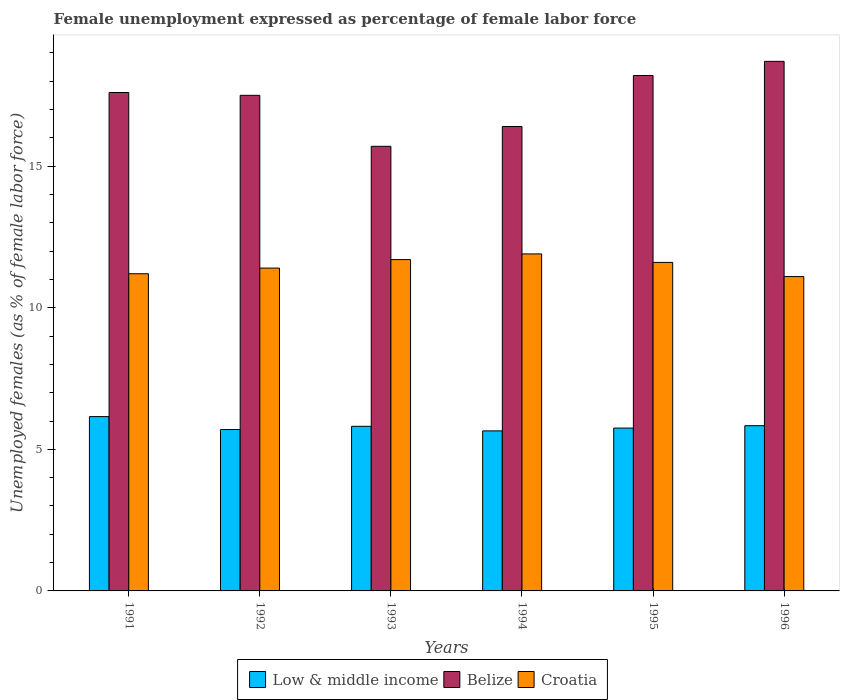How many different coloured bars are there?
Provide a short and direct response. 3. What is the label of the 5th group of bars from the left?
Your answer should be compact. 1995. In how many cases, is the number of bars for a given year not equal to the number of legend labels?
Provide a succinct answer. 0. What is the unemployment in females in in Belize in 1994?
Give a very brief answer. 16.4. Across all years, what is the maximum unemployment in females in in Belize?
Ensure brevity in your answer.  18.7. Across all years, what is the minimum unemployment in females in in Belize?
Provide a short and direct response. 15.7. In which year was the unemployment in females in in Low & middle income maximum?
Your answer should be very brief. 1991. What is the total unemployment in females in in Low & middle income in the graph?
Keep it short and to the point. 34.9. What is the difference between the unemployment in females in in Croatia in 1993 and that in 1994?
Your answer should be compact. -0.2. What is the difference between the unemployment in females in in Low & middle income in 1993 and the unemployment in females in in Croatia in 1995?
Provide a succinct answer. -5.79. What is the average unemployment in females in in Croatia per year?
Make the answer very short. 11.48. In the year 1992, what is the difference between the unemployment in females in in Low & middle income and unemployment in females in in Croatia?
Your answer should be compact. -5.7. What is the ratio of the unemployment in females in in Croatia in 1991 to that in 1996?
Provide a succinct answer. 1.01. Is the difference between the unemployment in females in in Low & middle income in 1991 and 1995 greater than the difference between the unemployment in females in in Croatia in 1991 and 1995?
Give a very brief answer. Yes. What is the difference between the highest and the lowest unemployment in females in in Belize?
Your answer should be very brief. 3. What does the 3rd bar from the left in 1991 represents?
Offer a very short reply. Croatia. What does the 2nd bar from the right in 1996 represents?
Provide a short and direct response. Belize. Is it the case that in every year, the sum of the unemployment in females in in Low & middle income and unemployment in females in in Belize is greater than the unemployment in females in in Croatia?
Make the answer very short. Yes. How many years are there in the graph?
Your answer should be very brief. 6. What is the difference between two consecutive major ticks on the Y-axis?
Give a very brief answer. 5. Are the values on the major ticks of Y-axis written in scientific E-notation?
Keep it short and to the point. No. Does the graph contain any zero values?
Your answer should be very brief. No. How many legend labels are there?
Make the answer very short. 3. How are the legend labels stacked?
Offer a very short reply. Horizontal. What is the title of the graph?
Make the answer very short. Female unemployment expressed as percentage of female labor force. Does "European Union" appear as one of the legend labels in the graph?
Make the answer very short. No. What is the label or title of the X-axis?
Offer a very short reply. Years. What is the label or title of the Y-axis?
Give a very brief answer. Unemployed females (as % of female labor force). What is the Unemployed females (as % of female labor force) in Low & middle income in 1991?
Your answer should be very brief. 6.16. What is the Unemployed females (as % of female labor force) in Belize in 1991?
Provide a succinct answer. 17.6. What is the Unemployed females (as % of female labor force) of Croatia in 1991?
Provide a succinct answer. 11.2. What is the Unemployed females (as % of female labor force) in Low & middle income in 1992?
Keep it short and to the point. 5.7. What is the Unemployed females (as % of female labor force) in Croatia in 1992?
Give a very brief answer. 11.4. What is the Unemployed females (as % of female labor force) in Low & middle income in 1993?
Your response must be concise. 5.81. What is the Unemployed females (as % of female labor force) of Belize in 1993?
Make the answer very short. 15.7. What is the Unemployed females (as % of female labor force) in Croatia in 1993?
Provide a short and direct response. 11.7. What is the Unemployed females (as % of female labor force) of Low & middle income in 1994?
Make the answer very short. 5.65. What is the Unemployed females (as % of female labor force) of Belize in 1994?
Your answer should be very brief. 16.4. What is the Unemployed females (as % of female labor force) in Croatia in 1994?
Offer a very short reply. 11.9. What is the Unemployed females (as % of female labor force) of Low & middle income in 1995?
Ensure brevity in your answer.  5.75. What is the Unemployed females (as % of female labor force) in Belize in 1995?
Your answer should be very brief. 18.2. What is the Unemployed females (as % of female labor force) of Croatia in 1995?
Offer a very short reply. 11.6. What is the Unemployed females (as % of female labor force) of Low & middle income in 1996?
Offer a terse response. 5.83. What is the Unemployed females (as % of female labor force) in Belize in 1996?
Provide a short and direct response. 18.7. What is the Unemployed females (as % of female labor force) in Croatia in 1996?
Keep it short and to the point. 11.1. Across all years, what is the maximum Unemployed females (as % of female labor force) of Low & middle income?
Ensure brevity in your answer.  6.16. Across all years, what is the maximum Unemployed females (as % of female labor force) of Belize?
Your response must be concise. 18.7. Across all years, what is the maximum Unemployed females (as % of female labor force) of Croatia?
Your response must be concise. 11.9. Across all years, what is the minimum Unemployed females (as % of female labor force) of Low & middle income?
Provide a succinct answer. 5.65. Across all years, what is the minimum Unemployed females (as % of female labor force) in Belize?
Provide a succinct answer. 15.7. Across all years, what is the minimum Unemployed females (as % of female labor force) in Croatia?
Your answer should be compact. 11.1. What is the total Unemployed females (as % of female labor force) of Low & middle income in the graph?
Your answer should be very brief. 34.9. What is the total Unemployed females (as % of female labor force) in Belize in the graph?
Offer a very short reply. 104.1. What is the total Unemployed females (as % of female labor force) of Croatia in the graph?
Your response must be concise. 68.9. What is the difference between the Unemployed females (as % of female labor force) in Low & middle income in 1991 and that in 1992?
Provide a short and direct response. 0.46. What is the difference between the Unemployed females (as % of female labor force) in Belize in 1991 and that in 1992?
Give a very brief answer. 0.1. What is the difference between the Unemployed females (as % of female labor force) of Low & middle income in 1991 and that in 1993?
Keep it short and to the point. 0.34. What is the difference between the Unemployed females (as % of female labor force) in Croatia in 1991 and that in 1993?
Ensure brevity in your answer.  -0.5. What is the difference between the Unemployed females (as % of female labor force) in Low & middle income in 1991 and that in 1994?
Offer a terse response. 0.5. What is the difference between the Unemployed females (as % of female labor force) in Low & middle income in 1991 and that in 1995?
Make the answer very short. 0.4. What is the difference between the Unemployed females (as % of female labor force) of Belize in 1991 and that in 1995?
Make the answer very short. -0.6. What is the difference between the Unemployed females (as % of female labor force) of Low & middle income in 1991 and that in 1996?
Provide a succinct answer. 0.32. What is the difference between the Unemployed females (as % of female labor force) of Belize in 1991 and that in 1996?
Make the answer very short. -1.1. What is the difference between the Unemployed females (as % of female labor force) of Croatia in 1991 and that in 1996?
Your response must be concise. 0.1. What is the difference between the Unemployed females (as % of female labor force) of Low & middle income in 1992 and that in 1993?
Provide a short and direct response. -0.11. What is the difference between the Unemployed females (as % of female labor force) of Low & middle income in 1992 and that in 1994?
Offer a very short reply. 0.05. What is the difference between the Unemployed females (as % of female labor force) of Belize in 1992 and that in 1994?
Provide a short and direct response. 1.1. What is the difference between the Unemployed females (as % of female labor force) of Low & middle income in 1992 and that in 1995?
Your answer should be compact. -0.05. What is the difference between the Unemployed females (as % of female labor force) of Croatia in 1992 and that in 1995?
Your answer should be compact. -0.2. What is the difference between the Unemployed females (as % of female labor force) in Low & middle income in 1992 and that in 1996?
Your response must be concise. -0.14. What is the difference between the Unemployed females (as % of female labor force) of Belize in 1992 and that in 1996?
Keep it short and to the point. -1.2. What is the difference between the Unemployed females (as % of female labor force) in Low & middle income in 1993 and that in 1994?
Provide a short and direct response. 0.16. What is the difference between the Unemployed females (as % of female labor force) of Belize in 1993 and that in 1994?
Provide a short and direct response. -0.7. What is the difference between the Unemployed females (as % of female labor force) in Croatia in 1993 and that in 1994?
Offer a very short reply. -0.2. What is the difference between the Unemployed females (as % of female labor force) in Low & middle income in 1993 and that in 1995?
Your response must be concise. 0.06. What is the difference between the Unemployed females (as % of female labor force) in Belize in 1993 and that in 1995?
Ensure brevity in your answer.  -2.5. What is the difference between the Unemployed females (as % of female labor force) of Croatia in 1993 and that in 1995?
Provide a succinct answer. 0.1. What is the difference between the Unemployed females (as % of female labor force) in Low & middle income in 1993 and that in 1996?
Provide a short and direct response. -0.02. What is the difference between the Unemployed females (as % of female labor force) in Low & middle income in 1994 and that in 1995?
Provide a short and direct response. -0.1. What is the difference between the Unemployed females (as % of female labor force) in Belize in 1994 and that in 1995?
Provide a succinct answer. -1.8. What is the difference between the Unemployed females (as % of female labor force) of Croatia in 1994 and that in 1995?
Provide a short and direct response. 0.3. What is the difference between the Unemployed females (as % of female labor force) in Low & middle income in 1994 and that in 1996?
Your response must be concise. -0.18. What is the difference between the Unemployed females (as % of female labor force) in Belize in 1994 and that in 1996?
Provide a short and direct response. -2.3. What is the difference between the Unemployed females (as % of female labor force) in Low & middle income in 1995 and that in 1996?
Give a very brief answer. -0.08. What is the difference between the Unemployed females (as % of female labor force) in Croatia in 1995 and that in 1996?
Ensure brevity in your answer.  0.5. What is the difference between the Unemployed females (as % of female labor force) in Low & middle income in 1991 and the Unemployed females (as % of female labor force) in Belize in 1992?
Provide a succinct answer. -11.34. What is the difference between the Unemployed females (as % of female labor force) in Low & middle income in 1991 and the Unemployed females (as % of female labor force) in Croatia in 1992?
Offer a very short reply. -5.24. What is the difference between the Unemployed females (as % of female labor force) of Low & middle income in 1991 and the Unemployed females (as % of female labor force) of Belize in 1993?
Offer a very short reply. -9.54. What is the difference between the Unemployed females (as % of female labor force) of Low & middle income in 1991 and the Unemployed females (as % of female labor force) of Croatia in 1993?
Your answer should be very brief. -5.54. What is the difference between the Unemployed females (as % of female labor force) in Belize in 1991 and the Unemployed females (as % of female labor force) in Croatia in 1993?
Make the answer very short. 5.9. What is the difference between the Unemployed females (as % of female labor force) in Low & middle income in 1991 and the Unemployed females (as % of female labor force) in Belize in 1994?
Give a very brief answer. -10.24. What is the difference between the Unemployed females (as % of female labor force) in Low & middle income in 1991 and the Unemployed females (as % of female labor force) in Croatia in 1994?
Offer a terse response. -5.74. What is the difference between the Unemployed females (as % of female labor force) of Low & middle income in 1991 and the Unemployed females (as % of female labor force) of Belize in 1995?
Give a very brief answer. -12.04. What is the difference between the Unemployed females (as % of female labor force) in Low & middle income in 1991 and the Unemployed females (as % of female labor force) in Croatia in 1995?
Your answer should be compact. -5.44. What is the difference between the Unemployed females (as % of female labor force) in Low & middle income in 1991 and the Unemployed females (as % of female labor force) in Belize in 1996?
Your answer should be very brief. -12.54. What is the difference between the Unemployed females (as % of female labor force) of Low & middle income in 1991 and the Unemployed females (as % of female labor force) of Croatia in 1996?
Your answer should be compact. -4.94. What is the difference between the Unemployed females (as % of female labor force) of Low & middle income in 1992 and the Unemployed females (as % of female labor force) of Belize in 1993?
Offer a very short reply. -10. What is the difference between the Unemployed females (as % of female labor force) in Low & middle income in 1992 and the Unemployed females (as % of female labor force) in Croatia in 1993?
Your answer should be compact. -6. What is the difference between the Unemployed females (as % of female labor force) in Low & middle income in 1992 and the Unemployed females (as % of female labor force) in Belize in 1994?
Make the answer very short. -10.7. What is the difference between the Unemployed females (as % of female labor force) of Low & middle income in 1992 and the Unemployed females (as % of female labor force) of Croatia in 1994?
Your answer should be compact. -6.2. What is the difference between the Unemployed females (as % of female labor force) of Belize in 1992 and the Unemployed females (as % of female labor force) of Croatia in 1994?
Make the answer very short. 5.6. What is the difference between the Unemployed females (as % of female labor force) of Low & middle income in 1992 and the Unemployed females (as % of female labor force) of Belize in 1995?
Provide a short and direct response. -12.5. What is the difference between the Unemployed females (as % of female labor force) of Low & middle income in 1992 and the Unemployed females (as % of female labor force) of Croatia in 1995?
Provide a succinct answer. -5.9. What is the difference between the Unemployed females (as % of female labor force) in Low & middle income in 1992 and the Unemployed females (as % of female labor force) in Belize in 1996?
Provide a succinct answer. -13. What is the difference between the Unemployed females (as % of female labor force) of Low & middle income in 1992 and the Unemployed females (as % of female labor force) of Croatia in 1996?
Provide a short and direct response. -5.4. What is the difference between the Unemployed females (as % of female labor force) in Belize in 1992 and the Unemployed females (as % of female labor force) in Croatia in 1996?
Offer a terse response. 6.4. What is the difference between the Unemployed females (as % of female labor force) of Low & middle income in 1993 and the Unemployed females (as % of female labor force) of Belize in 1994?
Your response must be concise. -10.59. What is the difference between the Unemployed females (as % of female labor force) of Low & middle income in 1993 and the Unemployed females (as % of female labor force) of Croatia in 1994?
Your answer should be compact. -6.09. What is the difference between the Unemployed females (as % of female labor force) of Belize in 1993 and the Unemployed females (as % of female labor force) of Croatia in 1994?
Give a very brief answer. 3.8. What is the difference between the Unemployed females (as % of female labor force) of Low & middle income in 1993 and the Unemployed females (as % of female labor force) of Belize in 1995?
Keep it short and to the point. -12.39. What is the difference between the Unemployed females (as % of female labor force) in Low & middle income in 1993 and the Unemployed females (as % of female labor force) in Croatia in 1995?
Give a very brief answer. -5.79. What is the difference between the Unemployed females (as % of female labor force) in Low & middle income in 1993 and the Unemployed females (as % of female labor force) in Belize in 1996?
Provide a succinct answer. -12.89. What is the difference between the Unemployed females (as % of female labor force) in Low & middle income in 1993 and the Unemployed females (as % of female labor force) in Croatia in 1996?
Keep it short and to the point. -5.29. What is the difference between the Unemployed females (as % of female labor force) of Low & middle income in 1994 and the Unemployed females (as % of female labor force) of Belize in 1995?
Keep it short and to the point. -12.55. What is the difference between the Unemployed females (as % of female labor force) of Low & middle income in 1994 and the Unemployed females (as % of female labor force) of Croatia in 1995?
Offer a terse response. -5.95. What is the difference between the Unemployed females (as % of female labor force) in Belize in 1994 and the Unemployed females (as % of female labor force) in Croatia in 1995?
Ensure brevity in your answer.  4.8. What is the difference between the Unemployed females (as % of female labor force) in Low & middle income in 1994 and the Unemployed females (as % of female labor force) in Belize in 1996?
Offer a terse response. -13.05. What is the difference between the Unemployed females (as % of female labor force) in Low & middle income in 1994 and the Unemployed females (as % of female labor force) in Croatia in 1996?
Provide a short and direct response. -5.45. What is the difference between the Unemployed females (as % of female labor force) in Low & middle income in 1995 and the Unemployed females (as % of female labor force) in Belize in 1996?
Your answer should be very brief. -12.95. What is the difference between the Unemployed females (as % of female labor force) in Low & middle income in 1995 and the Unemployed females (as % of female labor force) in Croatia in 1996?
Ensure brevity in your answer.  -5.35. What is the difference between the Unemployed females (as % of female labor force) in Belize in 1995 and the Unemployed females (as % of female labor force) in Croatia in 1996?
Make the answer very short. 7.1. What is the average Unemployed females (as % of female labor force) in Low & middle income per year?
Provide a succinct answer. 5.82. What is the average Unemployed females (as % of female labor force) in Belize per year?
Your answer should be compact. 17.35. What is the average Unemployed females (as % of female labor force) in Croatia per year?
Ensure brevity in your answer.  11.48. In the year 1991, what is the difference between the Unemployed females (as % of female labor force) of Low & middle income and Unemployed females (as % of female labor force) of Belize?
Keep it short and to the point. -11.44. In the year 1991, what is the difference between the Unemployed females (as % of female labor force) in Low & middle income and Unemployed females (as % of female labor force) in Croatia?
Ensure brevity in your answer.  -5.04. In the year 1991, what is the difference between the Unemployed females (as % of female labor force) in Belize and Unemployed females (as % of female labor force) in Croatia?
Make the answer very short. 6.4. In the year 1992, what is the difference between the Unemployed females (as % of female labor force) in Low & middle income and Unemployed females (as % of female labor force) in Belize?
Offer a terse response. -11.8. In the year 1992, what is the difference between the Unemployed females (as % of female labor force) in Low & middle income and Unemployed females (as % of female labor force) in Croatia?
Offer a terse response. -5.7. In the year 1992, what is the difference between the Unemployed females (as % of female labor force) in Belize and Unemployed females (as % of female labor force) in Croatia?
Offer a very short reply. 6.1. In the year 1993, what is the difference between the Unemployed females (as % of female labor force) in Low & middle income and Unemployed females (as % of female labor force) in Belize?
Provide a short and direct response. -9.89. In the year 1993, what is the difference between the Unemployed females (as % of female labor force) of Low & middle income and Unemployed females (as % of female labor force) of Croatia?
Your answer should be compact. -5.89. In the year 1994, what is the difference between the Unemployed females (as % of female labor force) of Low & middle income and Unemployed females (as % of female labor force) of Belize?
Provide a succinct answer. -10.75. In the year 1994, what is the difference between the Unemployed females (as % of female labor force) of Low & middle income and Unemployed females (as % of female labor force) of Croatia?
Make the answer very short. -6.25. In the year 1994, what is the difference between the Unemployed females (as % of female labor force) in Belize and Unemployed females (as % of female labor force) in Croatia?
Your response must be concise. 4.5. In the year 1995, what is the difference between the Unemployed females (as % of female labor force) of Low & middle income and Unemployed females (as % of female labor force) of Belize?
Your response must be concise. -12.45. In the year 1995, what is the difference between the Unemployed females (as % of female labor force) of Low & middle income and Unemployed females (as % of female labor force) of Croatia?
Keep it short and to the point. -5.85. In the year 1995, what is the difference between the Unemployed females (as % of female labor force) of Belize and Unemployed females (as % of female labor force) of Croatia?
Your answer should be compact. 6.6. In the year 1996, what is the difference between the Unemployed females (as % of female labor force) of Low & middle income and Unemployed females (as % of female labor force) of Belize?
Offer a terse response. -12.87. In the year 1996, what is the difference between the Unemployed females (as % of female labor force) in Low & middle income and Unemployed females (as % of female labor force) in Croatia?
Your answer should be compact. -5.27. In the year 1996, what is the difference between the Unemployed females (as % of female labor force) in Belize and Unemployed females (as % of female labor force) in Croatia?
Make the answer very short. 7.6. What is the ratio of the Unemployed females (as % of female labor force) of Low & middle income in 1991 to that in 1992?
Offer a very short reply. 1.08. What is the ratio of the Unemployed females (as % of female labor force) of Croatia in 1991 to that in 1992?
Keep it short and to the point. 0.98. What is the ratio of the Unemployed females (as % of female labor force) of Low & middle income in 1991 to that in 1993?
Keep it short and to the point. 1.06. What is the ratio of the Unemployed females (as % of female labor force) in Belize in 1991 to that in 1993?
Provide a short and direct response. 1.12. What is the ratio of the Unemployed females (as % of female labor force) in Croatia in 1991 to that in 1993?
Give a very brief answer. 0.96. What is the ratio of the Unemployed females (as % of female labor force) in Low & middle income in 1991 to that in 1994?
Ensure brevity in your answer.  1.09. What is the ratio of the Unemployed females (as % of female labor force) in Belize in 1991 to that in 1994?
Keep it short and to the point. 1.07. What is the ratio of the Unemployed females (as % of female labor force) in Low & middle income in 1991 to that in 1995?
Your response must be concise. 1.07. What is the ratio of the Unemployed females (as % of female labor force) in Belize in 1991 to that in 1995?
Your answer should be compact. 0.97. What is the ratio of the Unemployed females (as % of female labor force) of Croatia in 1991 to that in 1995?
Your answer should be very brief. 0.97. What is the ratio of the Unemployed females (as % of female labor force) in Low & middle income in 1991 to that in 1996?
Provide a succinct answer. 1.05. What is the ratio of the Unemployed females (as % of female labor force) of Croatia in 1991 to that in 1996?
Make the answer very short. 1.01. What is the ratio of the Unemployed females (as % of female labor force) in Low & middle income in 1992 to that in 1993?
Ensure brevity in your answer.  0.98. What is the ratio of the Unemployed females (as % of female labor force) in Belize in 1992 to that in 1993?
Ensure brevity in your answer.  1.11. What is the ratio of the Unemployed females (as % of female labor force) of Croatia in 1992 to that in 1993?
Ensure brevity in your answer.  0.97. What is the ratio of the Unemployed females (as % of female labor force) of Low & middle income in 1992 to that in 1994?
Your answer should be compact. 1.01. What is the ratio of the Unemployed females (as % of female labor force) in Belize in 1992 to that in 1994?
Keep it short and to the point. 1.07. What is the ratio of the Unemployed females (as % of female labor force) of Croatia in 1992 to that in 1994?
Offer a very short reply. 0.96. What is the ratio of the Unemployed females (as % of female labor force) of Belize in 1992 to that in 1995?
Offer a terse response. 0.96. What is the ratio of the Unemployed females (as % of female labor force) in Croatia in 1992 to that in 1995?
Make the answer very short. 0.98. What is the ratio of the Unemployed females (as % of female labor force) in Low & middle income in 1992 to that in 1996?
Provide a succinct answer. 0.98. What is the ratio of the Unemployed females (as % of female labor force) of Belize in 1992 to that in 1996?
Your response must be concise. 0.94. What is the ratio of the Unemployed females (as % of female labor force) in Croatia in 1992 to that in 1996?
Give a very brief answer. 1.03. What is the ratio of the Unemployed females (as % of female labor force) in Low & middle income in 1993 to that in 1994?
Your answer should be very brief. 1.03. What is the ratio of the Unemployed females (as % of female labor force) of Belize in 1993 to that in 1994?
Provide a succinct answer. 0.96. What is the ratio of the Unemployed females (as % of female labor force) in Croatia in 1993 to that in 1994?
Provide a short and direct response. 0.98. What is the ratio of the Unemployed females (as % of female labor force) of Low & middle income in 1993 to that in 1995?
Make the answer very short. 1.01. What is the ratio of the Unemployed females (as % of female labor force) in Belize in 1993 to that in 1995?
Ensure brevity in your answer.  0.86. What is the ratio of the Unemployed females (as % of female labor force) of Croatia in 1993 to that in 1995?
Your answer should be very brief. 1.01. What is the ratio of the Unemployed females (as % of female labor force) in Belize in 1993 to that in 1996?
Give a very brief answer. 0.84. What is the ratio of the Unemployed females (as % of female labor force) of Croatia in 1993 to that in 1996?
Your answer should be compact. 1.05. What is the ratio of the Unemployed females (as % of female labor force) in Low & middle income in 1994 to that in 1995?
Ensure brevity in your answer.  0.98. What is the ratio of the Unemployed females (as % of female labor force) in Belize in 1994 to that in 1995?
Offer a terse response. 0.9. What is the ratio of the Unemployed females (as % of female labor force) in Croatia in 1994 to that in 1995?
Give a very brief answer. 1.03. What is the ratio of the Unemployed females (as % of female labor force) in Low & middle income in 1994 to that in 1996?
Offer a terse response. 0.97. What is the ratio of the Unemployed females (as % of female labor force) of Belize in 1994 to that in 1996?
Offer a terse response. 0.88. What is the ratio of the Unemployed females (as % of female labor force) in Croatia in 1994 to that in 1996?
Ensure brevity in your answer.  1.07. What is the ratio of the Unemployed females (as % of female labor force) in Low & middle income in 1995 to that in 1996?
Offer a terse response. 0.99. What is the ratio of the Unemployed females (as % of female labor force) of Belize in 1995 to that in 1996?
Make the answer very short. 0.97. What is the ratio of the Unemployed females (as % of female labor force) of Croatia in 1995 to that in 1996?
Provide a succinct answer. 1.04. What is the difference between the highest and the second highest Unemployed females (as % of female labor force) in Low & middle income?
Make the answer very short. 0.32. What is the difference between the highest and the second highest Unemployed females (as % of female labor force) of Belize?
Make the answer very short. 0.5. What is the difference between the highest and the lowest Unemployed females (as % of female labor force) of Low & middle income?
Provide a short and direct response. 0.5. What is the difference between the highest and the lowest Unemployed females (as % of female labor force) of Belize?
Your answer should be compact. 3. 